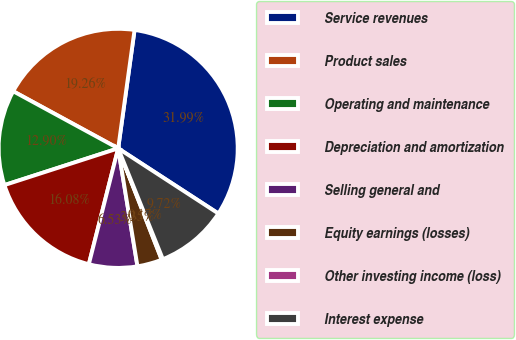Convert chart to OTSL. <chart><loc_0><loc_0><loc_500><loc_500><pie_chart><fcel>Service revenues<fcel>Product sales<fcel>Operating and maintenance<fcel>Depreciation and amortization<fcel>Selling general and<fcel>Equity earnings (losses)<fcel>Other investing income (loss)<fcel>Interest expense<nl><fcel>31.99%<fcel>19.26%<fcel>12.9%<fcel>16.08%<fcel>6.53%<fcel>3.35%<fcel>0.17%<fcel>9.72%<nl></chart> 